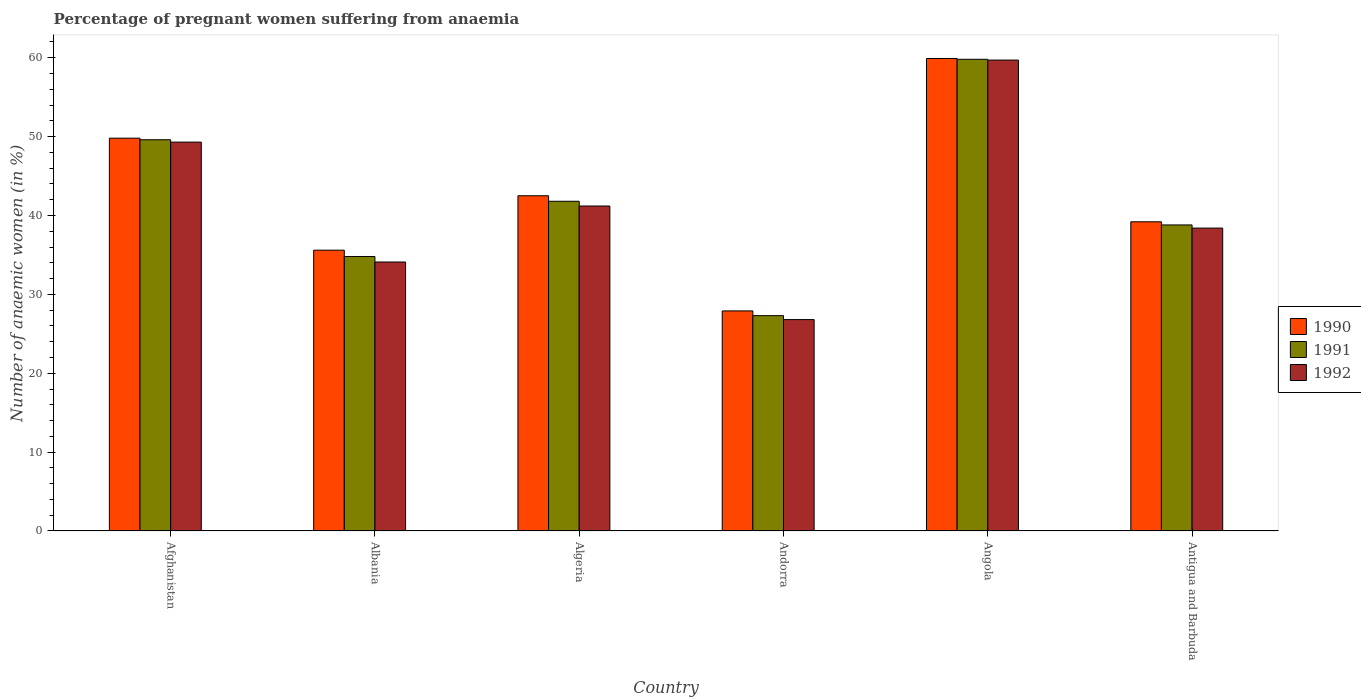How many different coloured bars are there?
Give a very brief answer. 3. How many groups of bars are there?
Your answer should be compact. 6. Are the number of bars per tick equal to the number of legend labels?
Your answer should be very brief. Yes. What is the label of the 4th group of bars from the left?
Ensure brevity in your answer.  Andorra. What is the number of anaemic women in 1991 in Albania?
Keep it short and to the point. 34.8. Across all countries, what is the maximum number of anaemic women in 1990?
Make the answer very short. 59.9. Across all countries, what is the minimum number of anaemic women in 1991?
Make the answer very short. 27.3. In which country was the number of anaemic women in 1992 maximum?
Your answer should be very brief. Angola. In which country was the number of anaemic women in 1992 minimum?
Keep it short and to the point. Andorra. What is the total number of anaemic women in 1991 in the graph?
Offer a very short reply. 252.1. What is the difference between the number of anaemic women in 1992 in Afghanistan and that in Andorra?
Your response must be concise. 22.5. What is the difference between the number of anaemic women in 1990 in Angola and the number of anaemic women in 1992 in Andorra?
Your answer should be very brief. 33.1. What is the average number of anaemic women in 1992 per country?
Your answer should be very brief. 41.58. What is the difference between the number of anaemic women of/in 1990 and number of anaemic women of/in 1992 in Albania?
Offer a terse response. 1.5. In how many countries, is the number of anaemic women in 1990 greater than 18 %?
Keep it short and to the point. 6. What is the ratio of the number of anaemic women in 1991 in Afghanistan to that in Angola?
Keep it short and to the point. 0.83. Is the difference between the number of anaemic women in 1990 in Afghanistan and Algeria greater than the difference between the number of anaemic women in 1992 in Afghanistan and Algeria?
Ensure brevity in your answer.  No. What is the difference between the highest and the second highest number of anaemic women in 1991?
Keep it short and to the point. -10.2. What does the 1st bar from the right in Antigua and Barbuda represents?
Your answer should be compact. 1992. How many bars are there?
Provide a short and direct response. 18. Are all the bars in the graph horizontal?
Provide a succinct answer. No. Does the graph contain any zero values?
Provide a short and direct response. No. Does the graph contain grids?
Ensure brevity in your answer.  No. Where does the legend appear in the graph?
Keep it short and to the point. Center right. How many legend labels are there?
Provide a succinct answer. 3. What is the title of the graph?
Your response must be concise. Percentage of pregnant women suffering from anaemia. What is the label or title of the Y-axis?
Your answer should be very brief. Number of anaemic women (in %). What is the Number of anaemic women (in %) of 1990 in Afghanistan?
Your response must be concise. 49.8. What is the Number of anaemic women (in %) in 1991 in Afghanistan?
Your answer should be very brief. 49.6. What is the Number of anaemic women (in %) in 1992 in Afghanistan?
Provide a succinct answer. 49.3. What is the Number of anaemic women (in %) in 1990 in Albania?
Provide a short and direct response. 35.6. What is the Number of anaemic women (in %) in 1991 in Albania?
Offer a terse response. 34.8. What is the Number of anaemic women (in %) of 1992 in Albania?
Keep it short and to the point. 34.1. What is the Number of anaemic women (in %) in 1990 in Algeria?
Keep it short and to the point. 42.5. What is the Number of anaemic women (in %) in 1991 in Algeria?
Offer a very short reply. 41.8. What is the Number of anaemic women (in %) in 1992 in Algeria?
Offer a terse response. 41.2. What is the Number of anaemic women (in %) of 1990 in Andorra?
Keep it short and to the point. 27.9. What is the Number of anaemic women (in %) of 1991 in Andorra?
Your answer should be very brief. 27.3. What is the Number of anaemic women (in %) in 1992 in Andorra?
Your response must be concise. 26.8. What is the Number of anaemic women (in %) in 1990 in Angola?
Your answer should be compact. 59.9. What is the Number of anaemic women (in %) in 1991 in Angola?
Provide a succinct answer. 59.8. What is the Number of anaemic women (in %) of 1992 in Angola?
Offer a terse response. 59.7. What is the Number of anaemic women (in %) in 1990 in Antigua and Barbuda?
Offer a terse response. 39.2. What is the Number of anaemic women (in %) in 1991 in Antigua and Barbuda?
Offer a terse response. 38.8. What is the Number of anaemic women (in %) in 1992 in Antigua and Barbuda?
Offer a terse response. 38.4. Across all countries, what is the maximum Number of anaemic women (in %) of 1990?
Your response must be concise. 59.9. Across all countries, what is the maximum Number of anaemic women (in %) of 1991?
Offer a very short reply. 59.8. Across all countries, what is the maximum Number of anaemic women (in %) of 1992?
Offer a terse response. 59.7. Across all countries, what is the minimum Number of anaemic women (in %) in 1990?
Your response must be concise. 27.9. Across all countries, what is the minimum Number of anaemic women (in %) in 1991?
Provide a succinct answer. 27.3. Across all countries, what is the minimum Number of anaemic women (in %) of 1992?
Keep it short and to the point. 26.8. What is the total Number of anaemic women (in %) of 1990 in the graph?
Offer a very short reply. 254.9. What is the total Number of anaemic women (in %) of 1991 in the graph?
Keep it short and to the point. 252.1. What is the total Number of anaemic women (in %) in 1992 in the graph?
Your answer should be compact. 249.5. What is the difference between the Number of anaemic women (in %) in 1990 in Afghanistan and that in Albania?
Provide a succinct answer. 14.2. What is the difference between the Number of anaemic women (in %) of 1991 in Afghanistan and that in Albania?
Give a very brief answer. 14.8. What is the difference between the Number of anaemic women (in %) in 1991 in Afghanistan and that in Algeria?
Ensure brevity in your answer.  7.8. What is the difference between the Number of anaemic women (in %) of 1992 in Afghanistan and that in Algeria?
Your answer should be very brief. 8.1. What is the difference between the Number of anaemic women (in %) in 1990 in Afghanistan and that in Andorra?
Offer a very short reply. 21.9. What is the difference between the Number of anaemic women (in %) of 1991 in Afghanistan and that in Andorra?
Keep it short and to the point. 22.3. What is the difference between the Number of anaemic women (in %) of 1990 in Afghanistan and that in Angola?
Ensure brevity in your answer.  -10.1. What is the difference between the Number of anaemic women (in %) of 1991 in Afghanistan and that in Angola?
Your answer should be compact. -10.2. What is the difference between the Number of anaemic women (in %) in 1991 in Albania and that in Algeria?
Keep it short and to the point. -7. What is the difference between the Number of anaemic women (in %) in 1992 in Albania and that in Algeria?
Provide a succinct answer. -7.1. What is the difference between the Number of anaemic women (in %) in 1990 in Albania and that in Andorra?
Give a very brief answer. 7.7. What is the difference between the Number of anaemic women (in %) in 1992 in Albania and that in Andorra?
Make the answer very short. 7.3. What is the difference between the Number of anaemic women (in %) of 1990 in Albania and that in Angola?
Provide a short and direct response. -24.3. What is the difference between the Number of anaemic women (in %) in 1991 in Albania and that in Angola?
Give a very brief answer. -25. What is the difference between the Number of anaemic women (in %) in 1992 in Albania and that in Angola?
Give a very brief answer. -25.6. What is the difference between the Number of anaemic women (in %) in 1992 in Albania and that in Antigua and Barbuda?
Offer a very short reply. -4.3. What is the difference between the Number of anaemic women (in %) in 1990 in Algeria and that in Andorra?
Provide a succinct answer. 14.6. What is the difference between the Number of anaemic women (in %) of 1991 in Algeria and that in Andorra?
Give a very brief answer. 14.5. What is the difference between the Number of anaemic women (in %) of 1990 in Algeria and that in Angola?
Make the answer very short. -17.4. What is the difference between the Number of anaemic women (in %) in 1992 in Algeria and that in Angola?
Offer a terse response. -18.5. What is the difference between the Number of anaemic women (in %) in 1990 in Algeria and that in Antigua and Barbuda?
Offer a terse response. 3.3. What is the difference between the Number of anaemic women (in %) in 1991 in Algeria and that in Antigua and Barbuda?
Keep it short and to the point. 3. What is the difference between the Number of anaemic women (in %) in 1992 in Algeria and that in Antigua and Barbuda?
Provide a succinct answer. 2.8. What is the difference between the Number of anaemic women (in %) of 1990 in Andorra and that in Angola?
Make the answer very short. -32. What is the difference between the Number of anaemic women (in %) of 1991 in Andorra and that in Angola?
Offer a terse response. -32.5. What is the difference between the Number of anaemic women (in %) in 1992 in Andorra and that in Angola?
Ensure brevity in your answer.  -32.9. What is the difference between the Number of anaemic women (in %) in 1991 in Andorra and that in Antigua and Barbuda?
Provide a succinct answer. -11.5. What is the difference between the Number of anaemic women (in %) of 1992 in Andorra and that in Antigua and Barbuda?
Offer a very short reply. -11.6. What is the difference between the Number of anaemic women (in %) of 1990 in Angola and that in Antigua and Barbuda?
Provide a short and direct response. 20.7. What is the difference between the Number of anaemic women (in %) in 1991 in Angola and that in Antigua and Barbuda?
Provide a succinct answer. 21. What is the difference between the Number of anaemic women (in %) of 1992 in Angola and that in Antigua and Barbuda?
Provide a succinct answer. 21.3. What is the difference between the Number of anaemic women (in %) of 1990 in Afghanistan and the Number of anaemic women (in %) of 1992 in Albania?
Your answer should be compact. 15.7. What is the difference between the Number of anaemic women (in %) in 1990 in Afghanistan and the Number of anaemic women (in %) in 1992 in Algeria?
Your response must be concise. 8.6. What is the difference between the Number of anaemic women (in %) in 1991 in Afghanistan and the Number of anaemic women (in %) in 1992 in Algeria?
Your answer should be compact. 8.4. What is the difference between the Number of anaemic women (in %) of 1990 in Afghanistan and the Number of anaemic women (in %) of 1991 in Andorra?
Provide a short and direct response. 22.5. What is the difference between the Number of anaemic women (in %) of 1991 in Afghanistan and the Number of anaemic women (in %) of 1992 in Andorra?
Provide a succinct answer. 22.8. What is the difference between the Number of anaemic women (in %) of 1991 in Afghanistan and the Number of anaemic women (in %) of 1992 in Angola?
Provide a short and direct response. -10.1. What is the difference between the Number of anaemic women (in %) in 1990 in Afghanistan and the Number of anaemic women (in %) in 1992 in Antigua and Barbuda?
Your response must be concise. 11.4. What is the difference between the Number of anaemic women (in %) of 1991 in Afghanistan and the Number of anaemic women (in %) of 1992 in Antigua and Barbuda?
Make the answer very short. 11.2. What is the difference between the Number of anaemic women (in %) of 1990 in Albania and the Number of anaemic women (in %) of 1991 in Algeria?
Provide a succinct answer. -6.2. What is the difference between the Number of anaemic women (in %) in 1990 in Albania and the Number of anaemic women (in %) in 1992 in Algeria?
Offer a very short reply. -5.6. What is the difference between the Number of anaemic women (in %) of 1991 in Albania and the Number of anaemic women (in %) of 1992 in Algeria?
Offer a very short reply. -6.4. What is the difference between the Number of anaemic women (in %) of 1990 in Albania and the Number of anaemic women (in %) of 1991 in Andorra?
Make the answer very short. 8.3. What is the difference between the Number of anaemic women (in %) in 1990 in Albania and the Number of anaemic women (in %) in 1992 in Andorra?
Keep it short and to the point. 8.8. What is the difference between the Number of anaemic women (in %) of 1990 in Albania and the Number of anaemic women (in %) of 1991 in Angola?
Your response must be concise. -24.2. What is the difference between the Number of anaemic women (in %) in 1990 in Albania and the Number of anaemic women (in %) in 1992 in Angola?
Give a very brief answer. -24.1. What is the difference between the Number of anaemic women (in %) in 1991 in Albania and the Number of anaemic women (in %) in 1992 in Angola?
Provide a succinct answer. -24.9. What is the difference between the Number of anaemic women (in %) in 1990 in Albania and the Number of anaemic women (in %) in 1991 in Antigua and Barbuda?
Ensure brevity in your answer.  -3.2. What is the difference between the Number of anaemic women (in %) in 1990 in Algeria and the Number of anaemic women (in %) in 1991 in Angola?
Give a very brief answer. -17.3. What is the difference between the Number of anaemic women (in %) in 1990 in Algeria and the Number of anaemic women (in %) in 1992 in Angola?
Your answer should be very brief. -17.2. What is the difference between the Number of anaemic women (in %) in 1991 in Algeria and the Number of anaemic women (in %) in 1992 in Angola?
Your answer should be compact. -17.9. What is the difference between the Number of anaemic women (in %) in 1990 in Algeria and the Number of anaemic women (in %) in 1991 in Antigua and Barbuda?
Give a very brief answer. 3.7. What is the difference between the Number of anaemic women (in %) of 1990 in Algeria and the Number of anaemic women (in %) of 1992 in Antigua and Barbuda?
Your answer should be very brief. 4.1. What is the difference between the Number of anaemic women (in %) in 1990 in Andorra and the Number of anaemic women (in %) in 1991 in Angola?
Provide a short and direct response. -31.9. What is the difference between the Number of anaemic women (in %) of 1990 in Andorra and the Number of anaemic women (in %) of 1992 in Angola?
Your answer should be very brief. -31.8. What is the difference between the Number of anaemic women (in %) of 1991 in Andorra and the Number of anaemic women (in %) of 1992 in Angola?
Keep it short and to the point. -32.4. What is the difference between the Number of anaemic women (in %) of 1990 in Angola and the Number of anaemic women (in %) of 1991 in Antigua and Barbuda?
Keep it short and to the point. 21.1. What is the difference between the Number of anaemic women (in %) of 1991 in Angola and the Number of anaemic women (in %) of 1992 in Antigua and Barbuda?
Provide a short and direct response. 21.4. What is the average Number of anaemic women (in %) in 1990 per country?
Give a very brief answer. 42.48. What is the average Number of anaemic women (in %) in 1991 per country?
Offer a terse response. 42.02. What is the average Number of anaemic women (in %) in 1992 per country?
Provide a short and direct response. 41.58. What is the difference between the Number of anaemic women (in %) of 1990 and Number of anaemic women (in %) of 1991 in Afghanistan?
Make the answer very short. 0.2. What is the difference between the Number of anaemic women (in %) in 1990 and Number of anaemic women (in %) in 1992 in Afghanistan?
Provide a short and direct response. 0.5. What is the difference between the Number of anaemic women (in %) in 1991 and Number of anaemic women (in %) in 1992 in Afghanistan?
Your response must be concise. 0.3. What is the difference between the Number of anaemic women (in %) of 1990 and Number of anaemic women (in %) of 1992 in Algeria?
Give a very brief answer. 1.3. What is the difference between the Number of anaemic women (in %) in 1991 and Number of anaemic women (in %) in 1992 in Algeria?
Your response must be concise. 0.6. What is the difference between the Number of anaemic women (in %) of 1990 and Number of anaemic women (in %) of 1991 in Andorra?
Your answer should be very brief. 0.6. What is the difference between the Number of anaemic women (in %) of 1990 and Number of anaemic women (in %) of 1992 in Andorra?
Make the answer very short. 1.1. What is the difference between the Number of anaemic women (in %) in 1991 and Number of anaemic women (in %) in 1992 in Angola?
Keep it short and to the point. 0.1. What is the difference between the Number of anaemic women (in %) in 1990 and Number of anaemic women (in %) in 1991 in Antigua and Barbuda?
Provide a succinct answer. 0.4. What is the difference between the Number of anaemic women (in %) of 1990 and Number of anaemic women (in %) of 1992 in Antigua and Barbuda?
Give a very brief answer. 0.8. What is the ratio of the Number of anaemic women (in %) of 1990 in Afghanistan to that in Albania?
Ensure brevity in your answer.  1.4. What is the ratio of the Number of anaemic women (in %) in 1991 in Afghanistan to that in Albania?
Offer a very short reply. 1.43. What is the ratio of the Number of anaemic women (in %) of 1992 in Afghanistan to that in Albania?
Provide a short and direct response. 1.45. What is the ratio of the Number of anaemic women (in %) in 1990 in Afghanistan to that in Algeria?
Give a very brief answer. 1.17. What is the ratio of the Number of anaemic women (in %) in 1991 in Afghanistan to that in Algeria?
Keep it short and to the point. 1.19. What is the ratio of the Number of anaemic women (in %) of 1992 in Afghanistan to that in Algeria?
Your response must be concise. 1.2. What is the ratio of the Number of anaemic women (in %) of 1990 in Afghanistan to that in Andorra?
Offer a terse response. 1.78. What is the ratio of the Number of anaemic women (in %) of 1991 in Afghanistan to that in Andorra?
Provide a short and direct response. 1.82. What is the ratio of the Number of anaemic women (in %) in 1992 in Afghanistan to that in Andorra?
Give a very brief answer. 1.84. What is the ratio of the Number of anaemic women (in %) in 1990 in Afghanistan to that in Angola?
Ensure brevity in your answer.  0.83. What is the ratio of the Number of anaemic women (in %) in 1991 in Afghanistan to that in Angola?
Make the answer very short. 0.83. What is the ratio of the Number of anaemic women (in %) of 1992 in Afghanistan to that in Angola?
Your answer should be very brief. 0.83. What is the ratio of the Number of anaemic women (in %) of 1990 in Afghanistan to that in Antigua and Barbuda?
Your response must be concise. 1.27. What is the ratio of the Number of anaemic women (in %) in 1991 in Afghanistan to that in Antigua and Barbuda?
Offer a terse response. 1.28. What is the ratio of the Number of anaemic women (in %) of 1992 in Afghanistan to that in Antigua and Barbuda?
Ensure brevity in your answer.  1.28. What is the ratio of the Number of anaemic women (in %) of 1990 in Albania to that in Algeria?
Your answer should be compact. 0.84. What is the ratio of the Number of anaemic women (in %) in 1991 in Albania to that in Algeria?
Offer a terse response. 0.83. What is the ratio of the Number of anaemic women (in %) in 1992 in Albania to that in Algeria?
Keep it short and to the point. 0.83. What is the ratio of the Number of anaemic women (in %) in 1990 in Albania to that in Andorra?
Your answer should be compact. 1.28. What is the ratio of the Number of anaemic women (in %) in 1991 in Albania to that in Andorra?
Make the answer very short. 1.27. What is the ratio of the Number of anaemic women (in %) in 1992 in Albania to that in Andorra?
Provide a succinct answer. 1.27. What is the ratio of the Number of anaemic women (in %) of 1990 in Albania to that in Angola?
Your answer should be very brief. 0.59. What is the ratio of the Number of anaemic women (in %) of 1991 in Albania to that in Angola?
Your answer should be compact. 0.58. What is the ratio of the Number of anaemic women (in %) of 1992 in Albania to that in Angola?
Provide a short and direct response. 0.57. What is the ratio of the Number of anaemic women (in %) in 1990 in Albania to that in Antigua and Barbuda?
Provide a succinct answer. 0.91. What is the ratio of the Number of anaemic women (in %) in 1991 in Albania to that in Antigua and Barbuda?
Ensure brevity in your answer.  0.9. What is the ratio of the Number of anaemic women (in %) of 1992 in Albania to that in Antigua and Barbuda?
Provide a short and direct response. 0.89. What is the ratio of the Number of anaemic women (in %) of 1990 in Algeria to that in Andorra?
Your response must be concise. 1.52. What is the ratio of the Number of anaemic women (in %) in 1991 in Algeria to that in Andorra?
Offer a terse response. 1.53. What is the ratio of the Number of anaemic women (in %) in 1992 in Algeria to that in Andorra?
Keep it short and to the point. 1.54. What is the ratio of the Number of anaemic women (in %) of 1990 in Algeria to that in Angola?
Give a very brief answer. 0.71. What is the ratio of the Number of anaemic women (in %) of 1991 in Algeria to that in Angola?
Ensure brevity in your answer.  0.7. What is the ratio of the Number of anaemic women (in %) in 1992 in Algeria to that in Angola?
Your answer should be very brief. 0.69. What is the ratio of the Number of anaemic women (in %) in 1990 in Algeria to that in Antigua and Barbuda?
Your answer should be very brief. 1.08. What is the ratio of the Number of anaemic women (in %) in 1991 in Algeria to that in Antigua and Barbuda?
Your answer should be compact. 1.08. What is the ratio of the Number of anaemic women (in %) of 1992 in Algeria to that in Antigua and Barbuda?
Offer a terse response. 1.07. What is the ratio of the Number of anaemic women (in %) in 1990 in Andorra to that in Angola?
Provide a succinct answer. 0.47. What is the ratio of the Number of anaemic women (in %) of 1991 in Andorra to that in Angola?
Keep it short and to the point. 0.46. What is the ratio of the Number of anaemic women (in %) in 1992 in Andorra to that in Angola?
Make the answer very short. 0.45. What is the ratio of the Number of anaemic women (in %) in 1990 in Andorra to that in Antigua and Barbuda?
Keep it short and to the point. 0.71. What is the ratio of the Number of anaemic women (in %) in 1991 in Andorra to that in Antigua and Barbuda?
Provide a succinct answer. 0.7. What is the ratio of the Number of anaemic women (in %) of 1992 in Andorra to that in Antigua and Barbuda?
Offer a very short reply. 0.7. What is the ratio of the Number of anaemic women (in %) in 1990 in Angola to that in Antigua and Barbuda?
Offer a terse response. 1.53. What is the ratio of the Number of anaemic women (in %) of 1991 in Angola to that in Antigua and Barbuda?
Offer a terse response. 1.54. What is the ratio of the Number of anaemic women (in %) of 1992 in Angola to that in Antigua and Barbuda?
Your answer should be compact. 1.55. What is the difference between the highest and the second highest Number of anaemic women (in %) in 1990?
Provide a short and direct response. 10.1. What is the difference between the highest and the second highest Number of anaemic women (in %) of 1991?
Make the answer very short. 10.2. What is the difference between the highest and the second highest Number of anaemic women (in %) of 1992?
Offer a very short reply. 10.4. What is the difference between the highest and the lowest Number of anaemic women (in %) of 1991?
Provide a succinct answer. 32.5. What is the difference between the highest and the lowest Number of anaemic women (in %) in 1992?
Offer a very short reply. 32.9. 